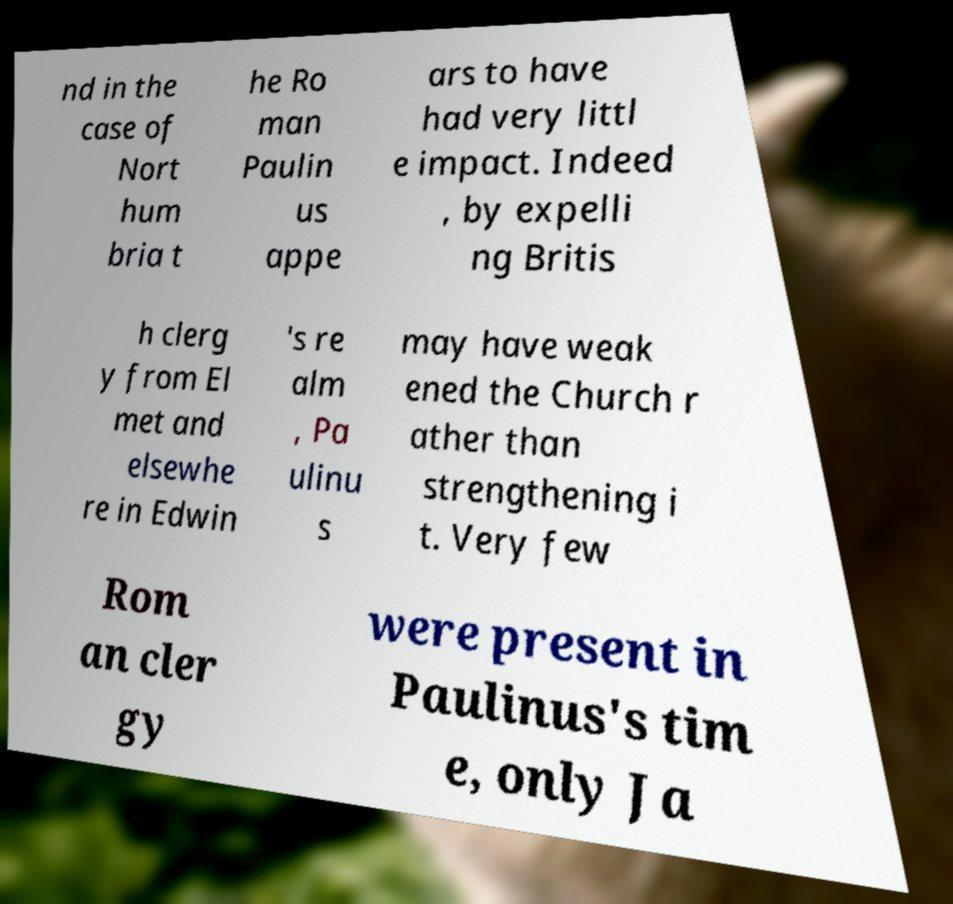Could you assist in decoding the text presented in this image and type it out clearly? nd in the case of Nort hum bria t he Ro man Paulin us appe ars to have had very littl e impact. Indeed , by expelli ng Britis h clerg y from El met and elsewhe re in Edwin 's re alm , Pa ulinu s may have weak ened the Church r ather than strengthening i t. Very few Rom an cler gy were present in Paulinus's tim e, only Ja 